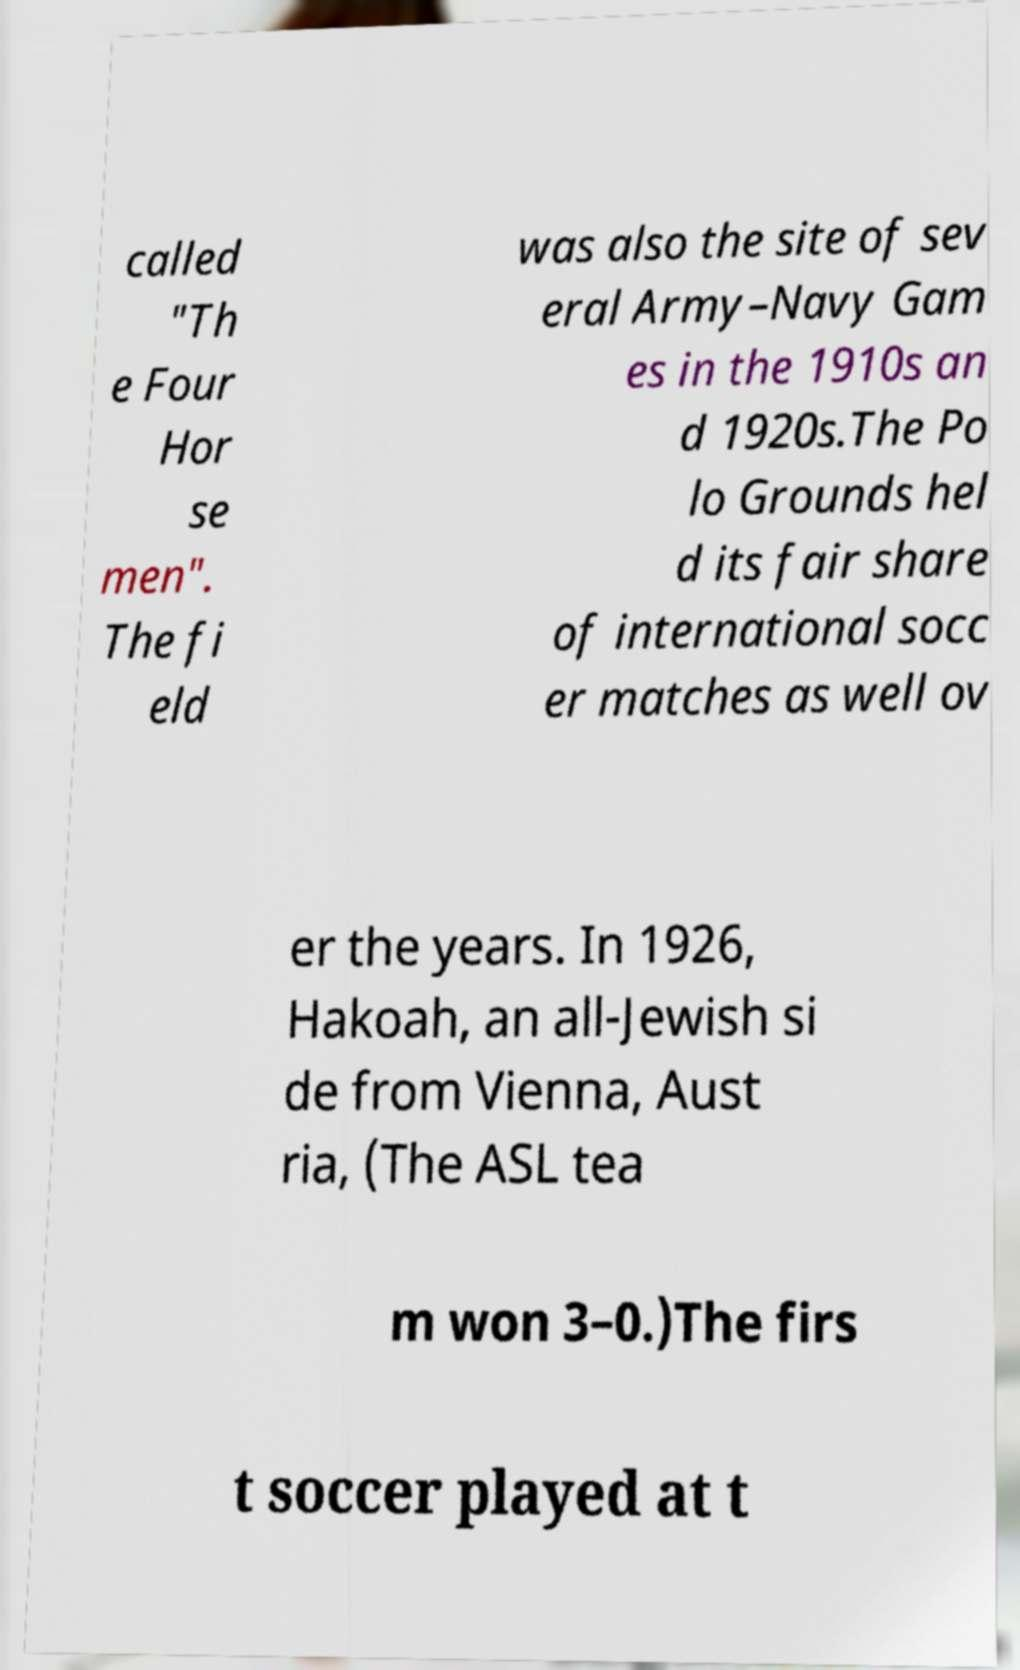I need the written content from this picture converted into text. Can you do that? called "Th e Four Hor se men". The fi eld was also the site of sev eral Army–Navy Gam es in the 1910s an d 1920s.The Po lo Grounds hel d its fair share of international socc er matches as well ov er the years. In 1926, Hakoah, an all-Jewish si de from Vienna, Aust ria, (The ASL tea m won 3–0.)The firs t soccer played at t 